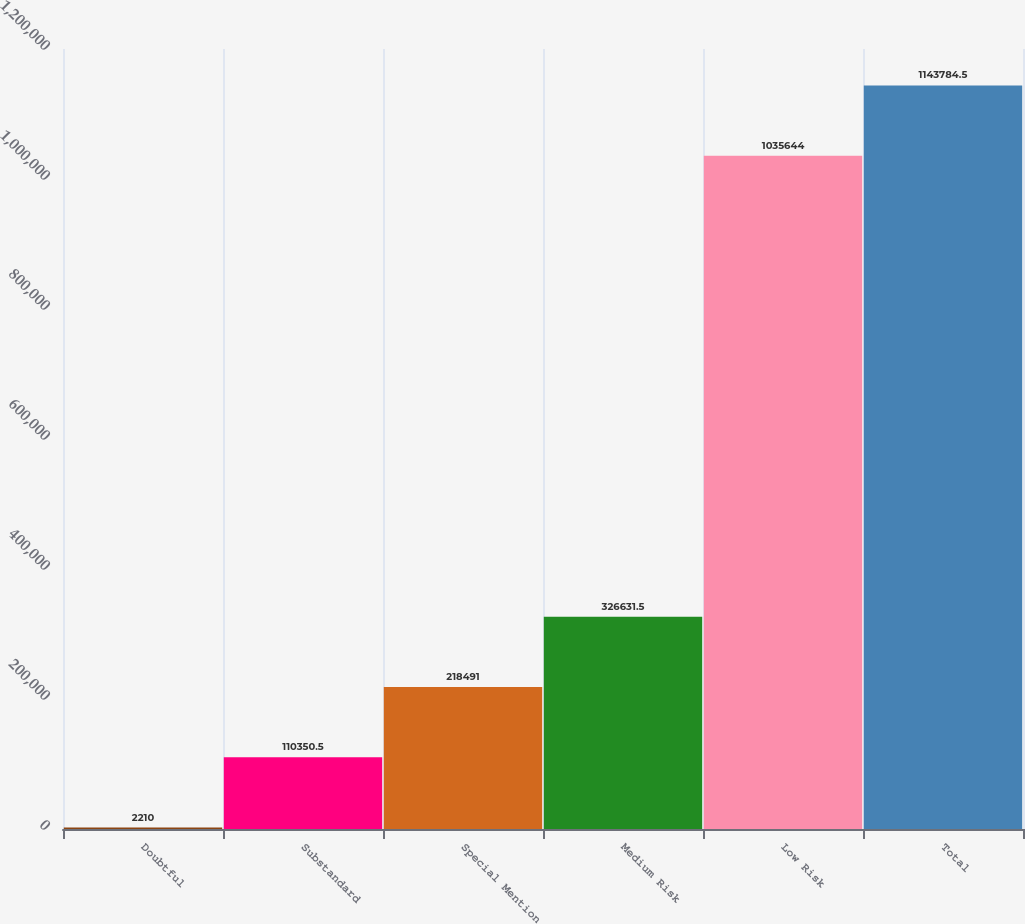Convert chart to OTSL. <chart><loc_0><loc_0><loc_500><loc_500><bar_chart><fcel>Doubtful<fcel>Substandard<fcel>Special Mention<fcel>Medium Risk<fcel>Low Risk<fcel>Total<nl><fcel>2210<fcel>110350<fcel>218491<fcel>326632<fcel>1.03564e+06<fcel>1.14378e+06<nl></chart> 